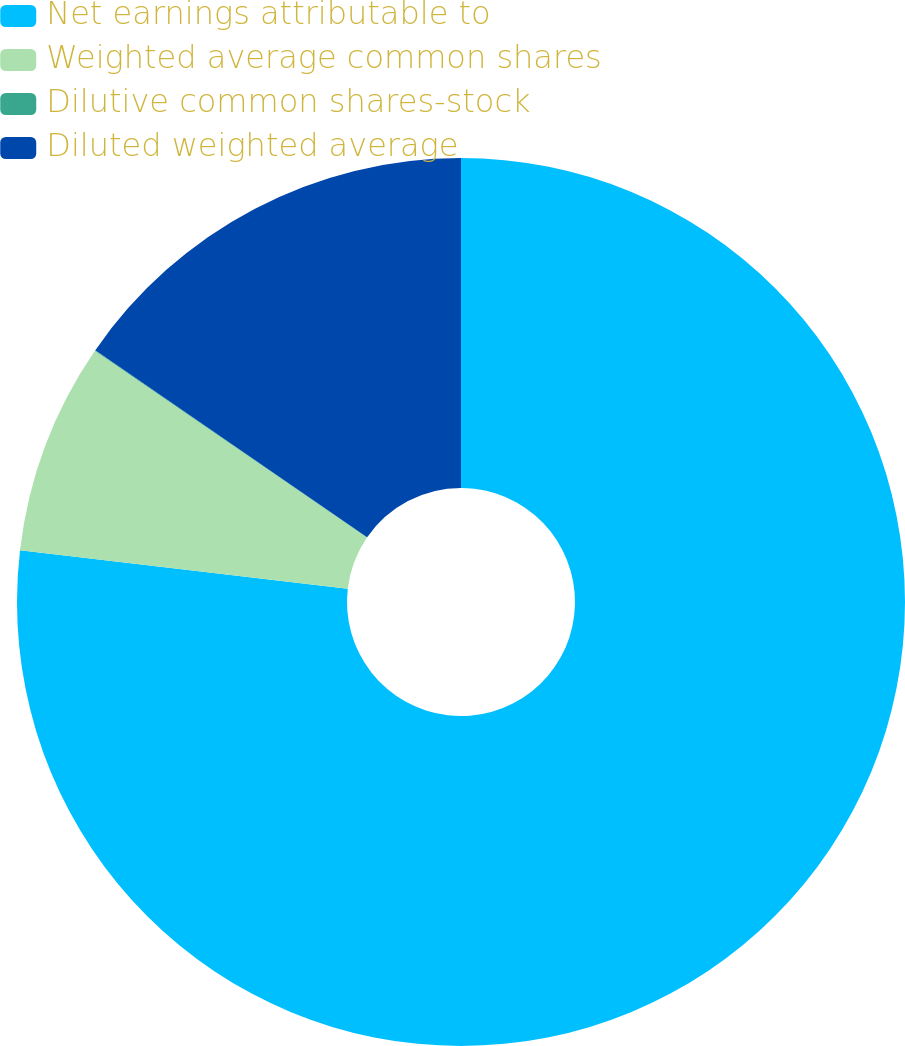<chart> <loc_0><loc_0><loc_500><loc_500><pie_chart><fcel>Net earnings attributable to<fcel>Weighted average common shares<fcel>Dilutive common shares-stock<fcel>Diluted weighted average<nl><fcel>76.86%<fcel>7.71%<fcel>0.03%<fcel>15.4%<nl></chart> 